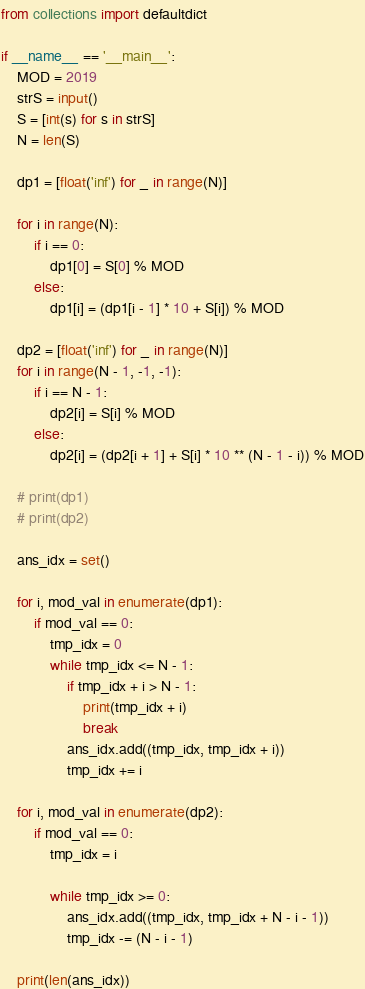<code> <loc_0><loc_0><loc_500><loc_500><_Python_>from collections import defaultdict

if __name__ == '__main__':
    MOD = 2019
    strS = input()
    S = [int(s) for s in strS]
    N = len(S)

    dp1 = [float('inf') for _ in range(N)]

    for i in range(N):
        if i == 0:
            dp1[0] = S[0] % MOD
        else:
            dp1[i] = (dp1[i - 1] * 10 + S[i]) % MOD

    dp2 = [float('inf') for _ in range(N)]
    for i in range(N - 1, -1, -1):
        if i == N - 1:
            dp2[i] = S[i] % MOD
        else:
            dp2[i] = (dp2[i + 1] + S[i] * 10 ** (N - 1 - i)) % MOD

    # print(dp1)
    # print(dp2)

    ans_idx = set()

    for i, mod_val in enumerate(dp1):
        if mod_val == 0:
            tmp_idx = 0
            while tmp_idx <= N - 1:
                if tmp_idx + i > N - 1:
                    print(tmp_idx + i)
                    break
                ans_idx.add((tmp_idx, tmp_idx + i))
                tmp_idx += i

    for i, mod_val in enumerate(dp2):
        if mod_val == 0:
            tmp_idx = i

            while tmp_idx >= 0:
                ans_idx.add((tmp_idx, tmp_idx + N - i - 1))
                tmp_idx -= (N - i - 1)

    print(len(ans_idx))
</code> 